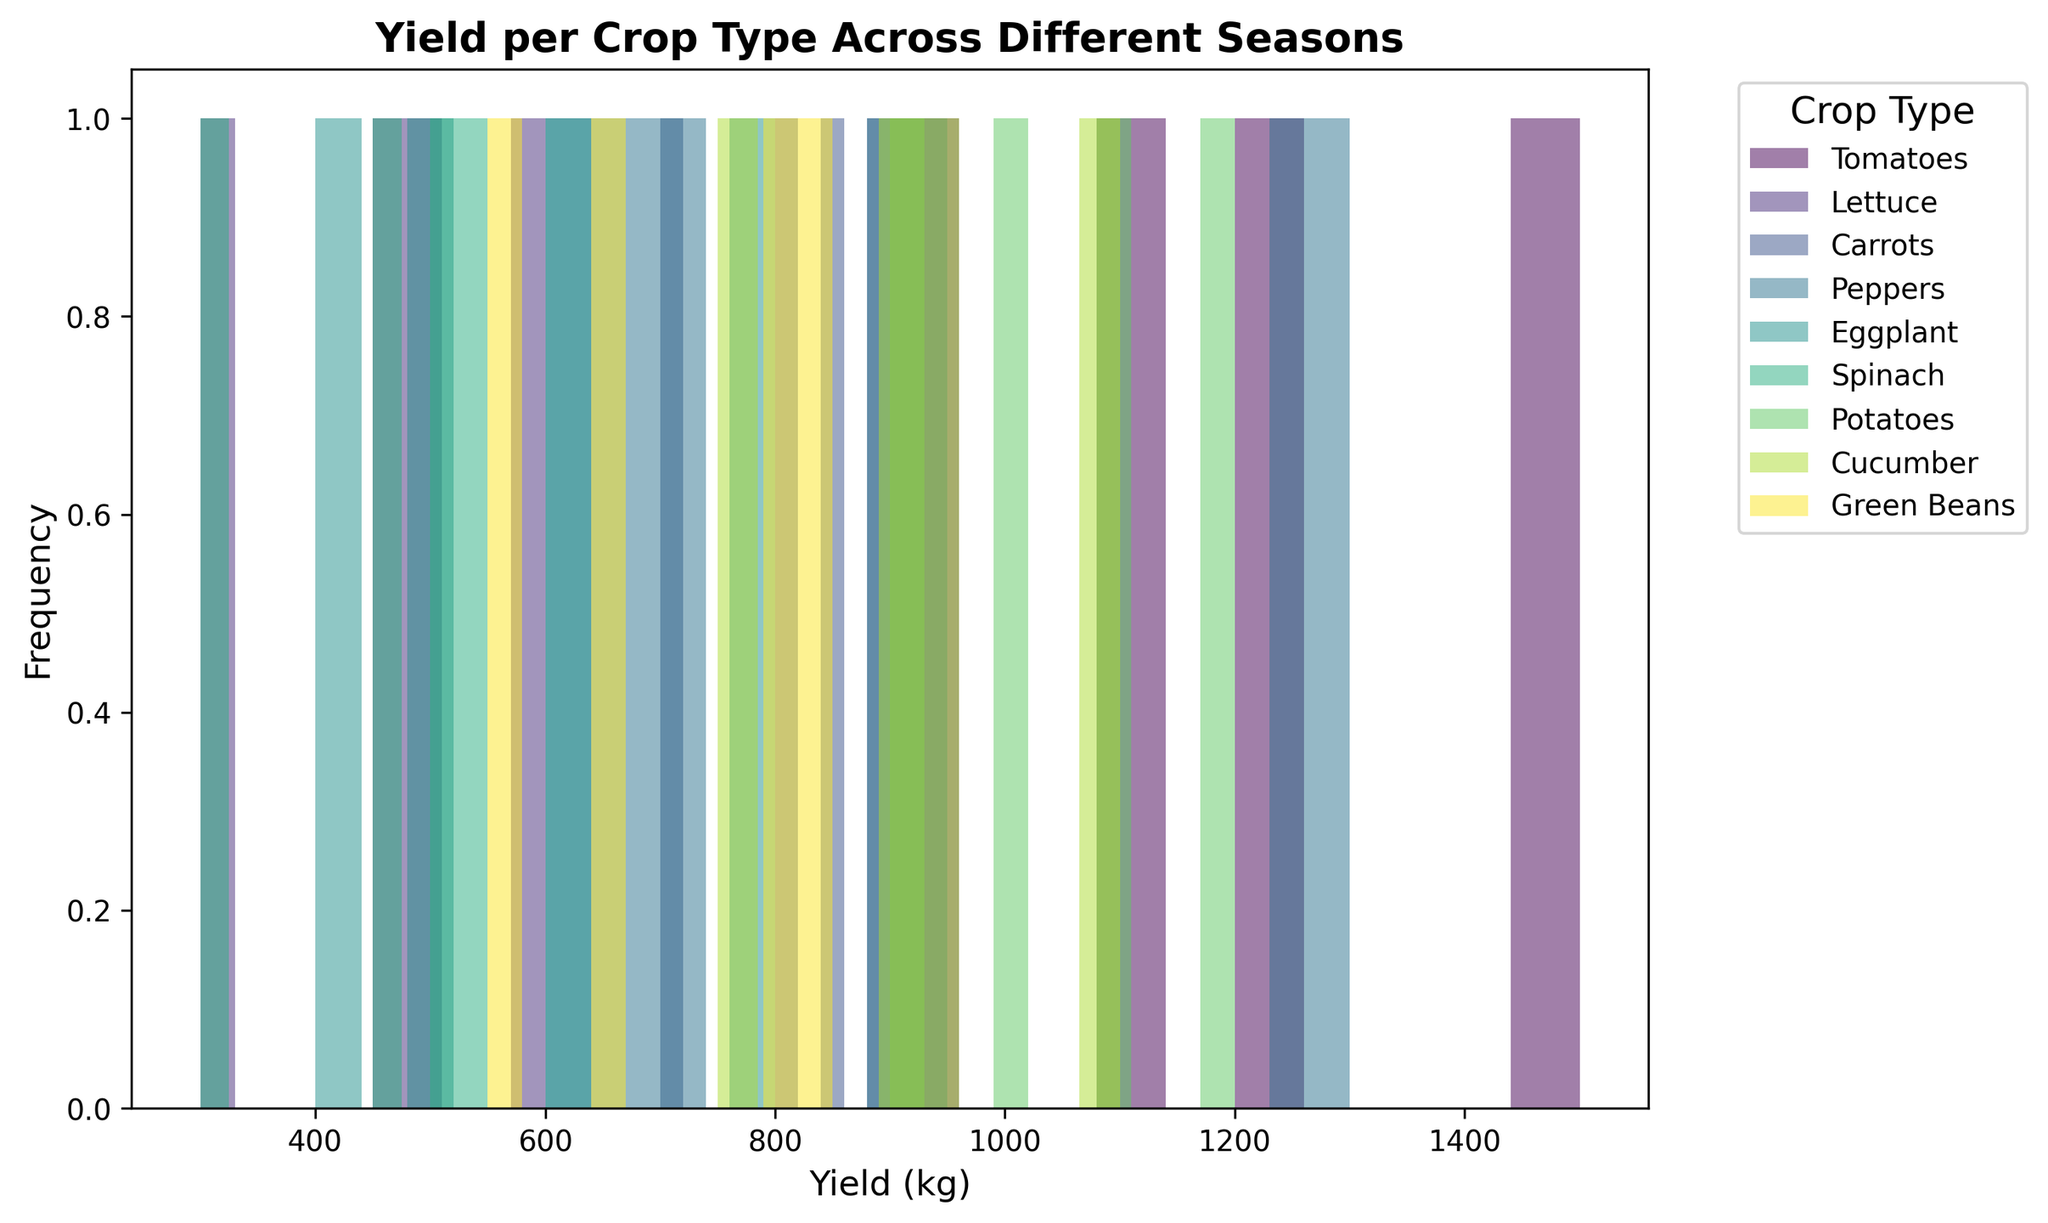Which crop has the highest yield in summer? Look at the highest bars in the summer (the second set of bars). Identify the crop type by checking the labels and colors.
Answer: Peppers Which crop shows the most consistent yield across all seasons? Check which crop type has the least variation in the height of its bars across all seasons.
Answer: Potatoes What is the median yield for Tomatoes across all seasons? Identify the yield values for Tomatoes for all seasons (1200, 1500, 1100, 900). Arrange them in ascending order (900, 1100, 1200, 1500). The median is the average of the two middle numbers (1100 and 1200), so (1100+1200)/2 = 1150.
Answer: 1150 How does the yield of Cucumbers in winter compare to that of summer? Look at the height of the bars for Cucumbers in winter and summer. Note the values and compare them: Winter (750 kg) and Summer (1100 kg). Cucumbers yield more in summer than in winter.
Answer: Summer > Winter Which crop type has the highest peak yield in any season? Look for the tallest bar in the entire histogram and identify the crop type associated with it.
Answer: Peppers What is the range of yields for Spinach across different seasons? Identify the yield values for Spinach (550, 450, 500, 300). Find the difference between the maximum and minimum yields: 550 - 300 = 250.
Answer: 250 Which two crops have the closest yields in autumn? Compare the height of the bars for all crops in autumn. Identify the two crops with bars of nearly equal height.
Answer: Carrots and Cucumber What is the total yield for Lettuce across all seasons? Sum the yield values for Lettuce: 600 + 500 + 450 + 300.
Answer: 1850 kg In which season does Eggplant yield the lowest? Identify the shortest bar for Eggplant across all seasons and note the corresponding season.
Answer: Winter What is the average yield of Green Beans across all seasons? Identify the yields for Green Beans (650, 850, 800, 550), sum them (650 + 850 + 800 + 550 = 2850), and divide by the number of seasons (4): 2850/4.
Answer: 712.5 kg 